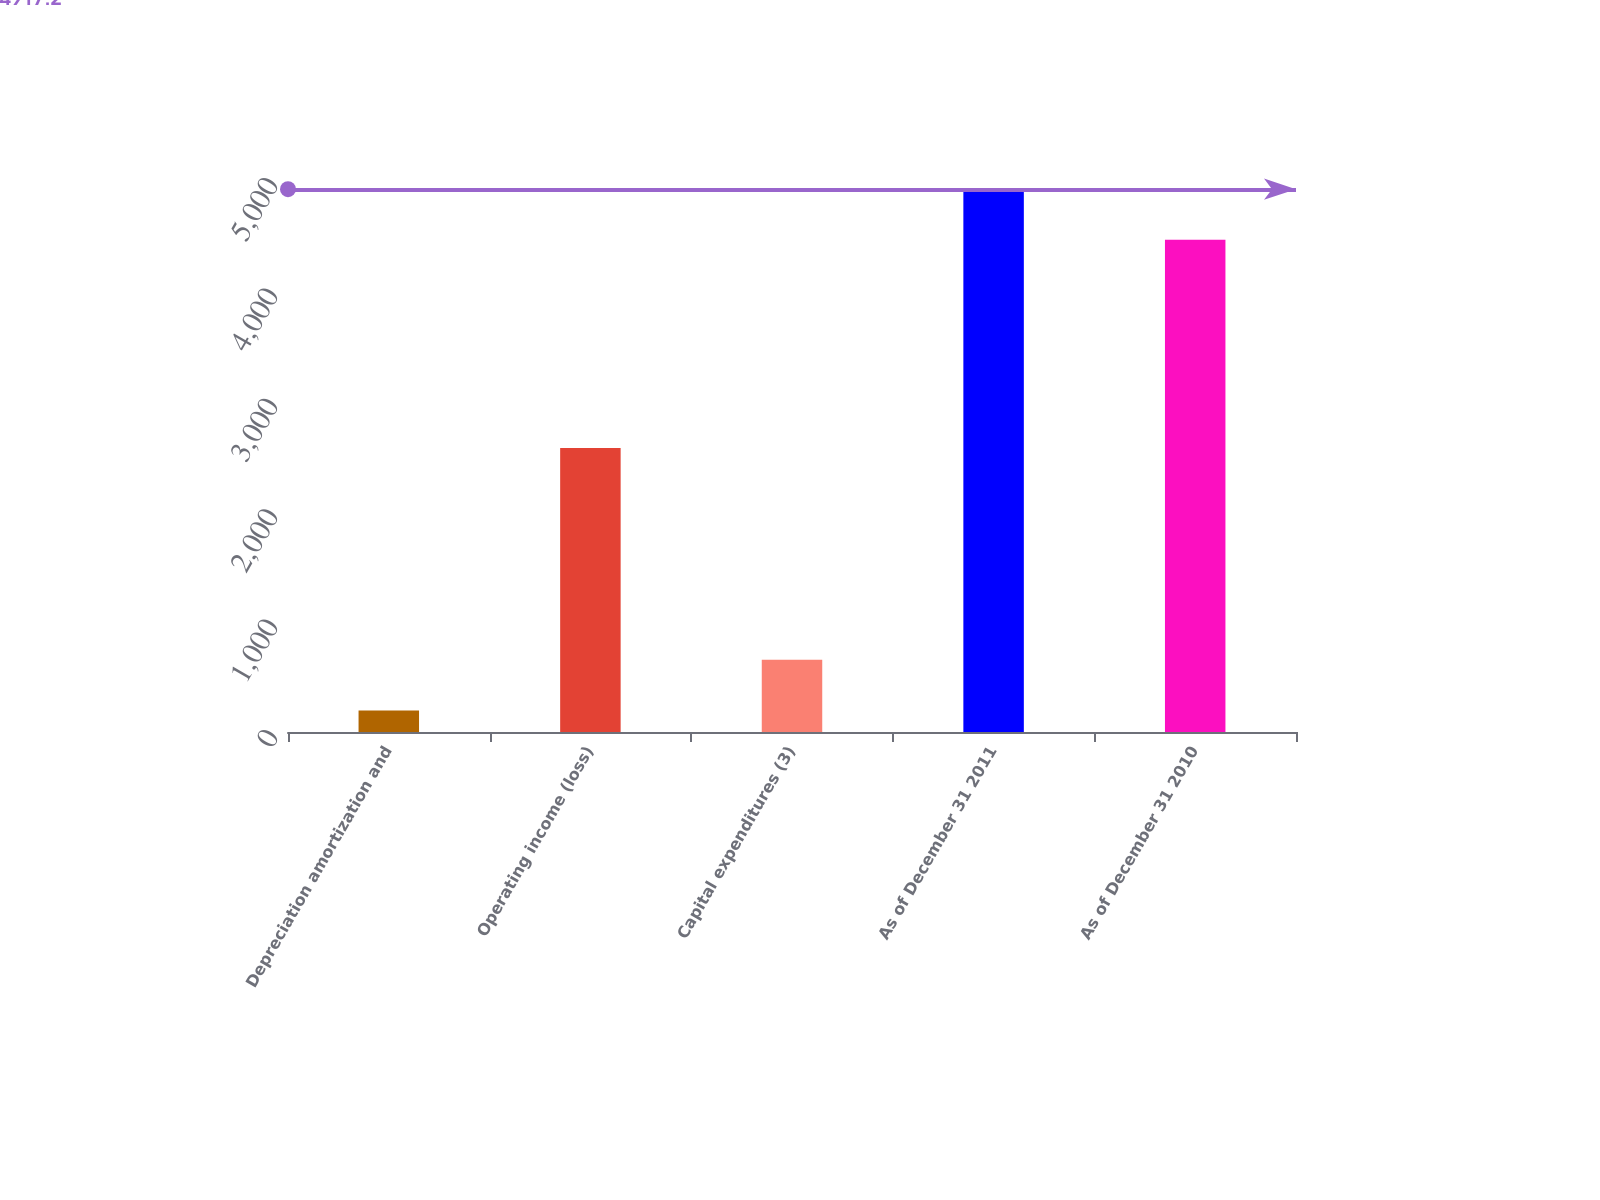Convert chart. <chart><loc_0><loc_0><loc_500><loc_500><bar_chart><fcel>Depreciation amortization and<fcel>Operating income (loss)<fcel>Capital expenditures (3)<fcel>As of December 31 2011<fcel>As of December 31 2010<nl><fcel>195<fcel>2573<fcel>654.2<fcel>4917.2<fcel>4458<nl></chart> 